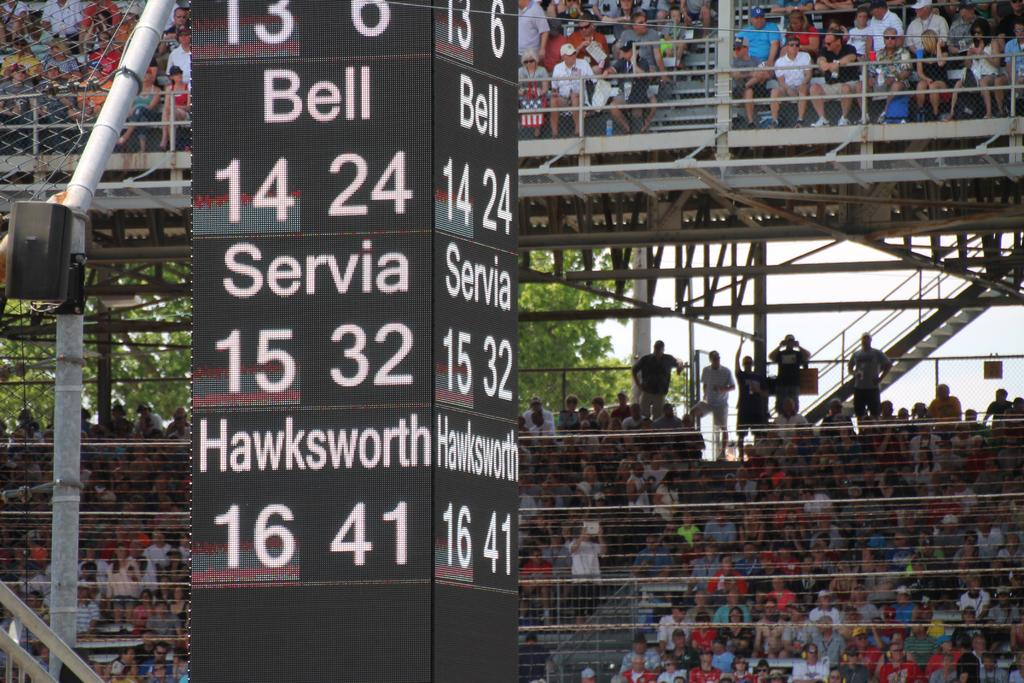Provide a one-sentence caption for the provided image. Stadium score board listing Bell 14 24, Servia 15 32,  Hawkworth 16 41 in digital on all sides. 